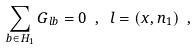Convert formula to latex. <formula><loc_0><loc_0><loc_500><loc_500>\sum _ { b \in H _ { 1 } } G _ { l b } = 0 \ , \ l = ( x , n _ { 1 } ) \ ,</formula> 